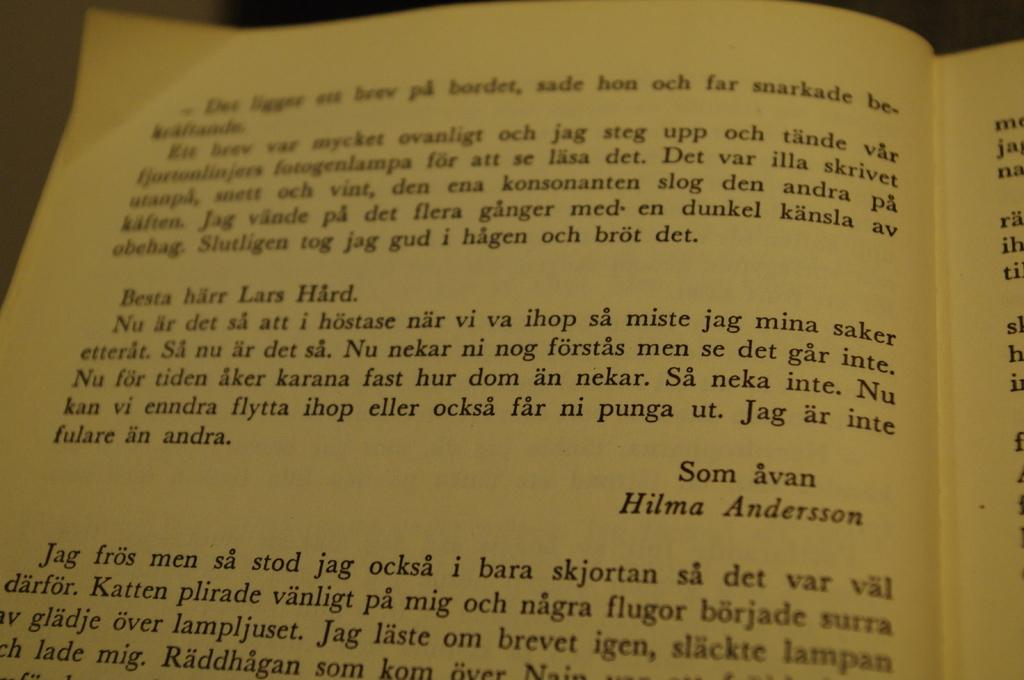Provide a one-sentence caption for the provided image. The current page includes a note to Lars Hard from Hilma Andersson. 